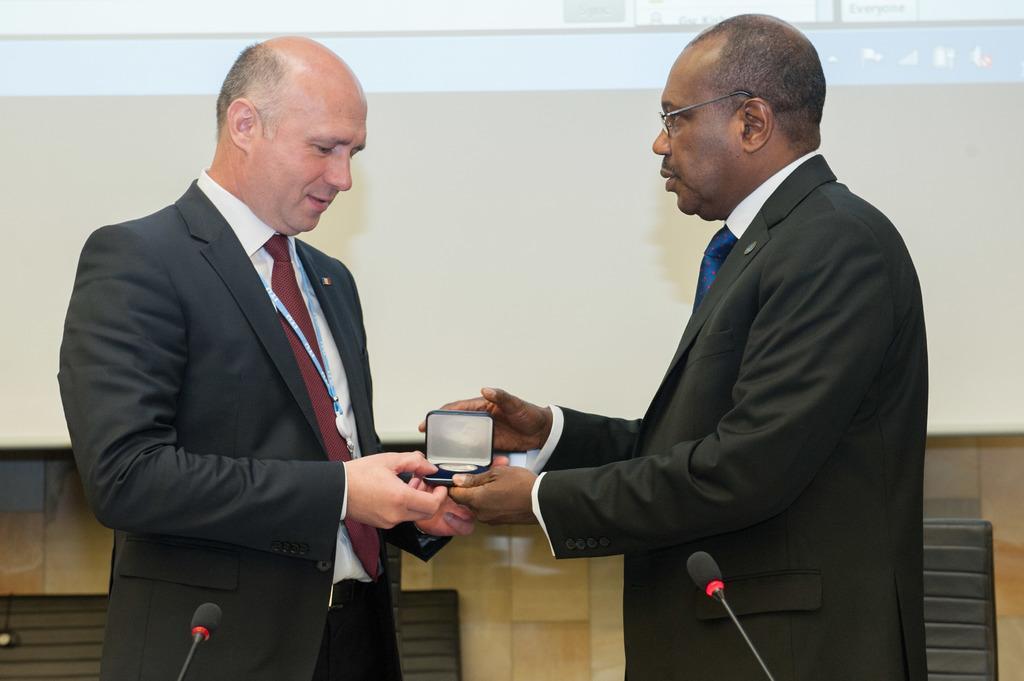Please provide a concise description of this image. Man on the left corner of the picture wearing black blazer is holding a small blue color box. Beside him, the man in black blazer is giving that box to the man on the opposite side. He is even wearing spectacles. Behind them, we see white wall and chairs. At the bottom of the picture, we see microphones. This picture is clicked in a conference hall. 